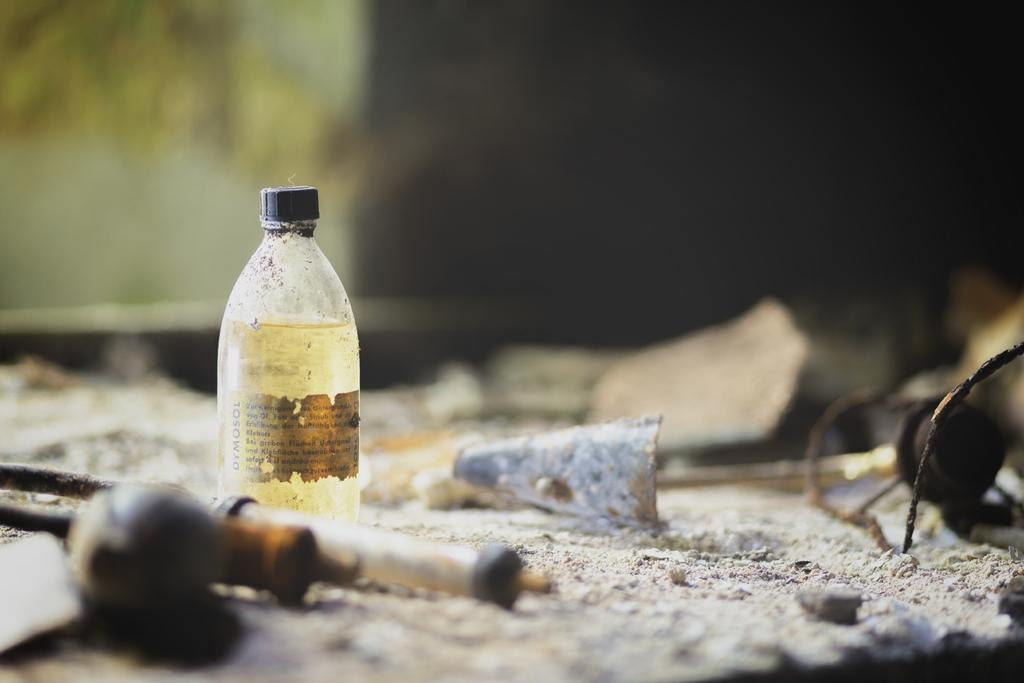What object can be seen in the image with a black lid? There is a bottle in the image with a black lid. What else is present in the image besides the bottle? There are tools present in the image. Where are the tools located in the image? The tools are kept on the ground. Can you see a patch of feathers belonging to a hen in the image? There is no patch of feathers or hen present in the image. 